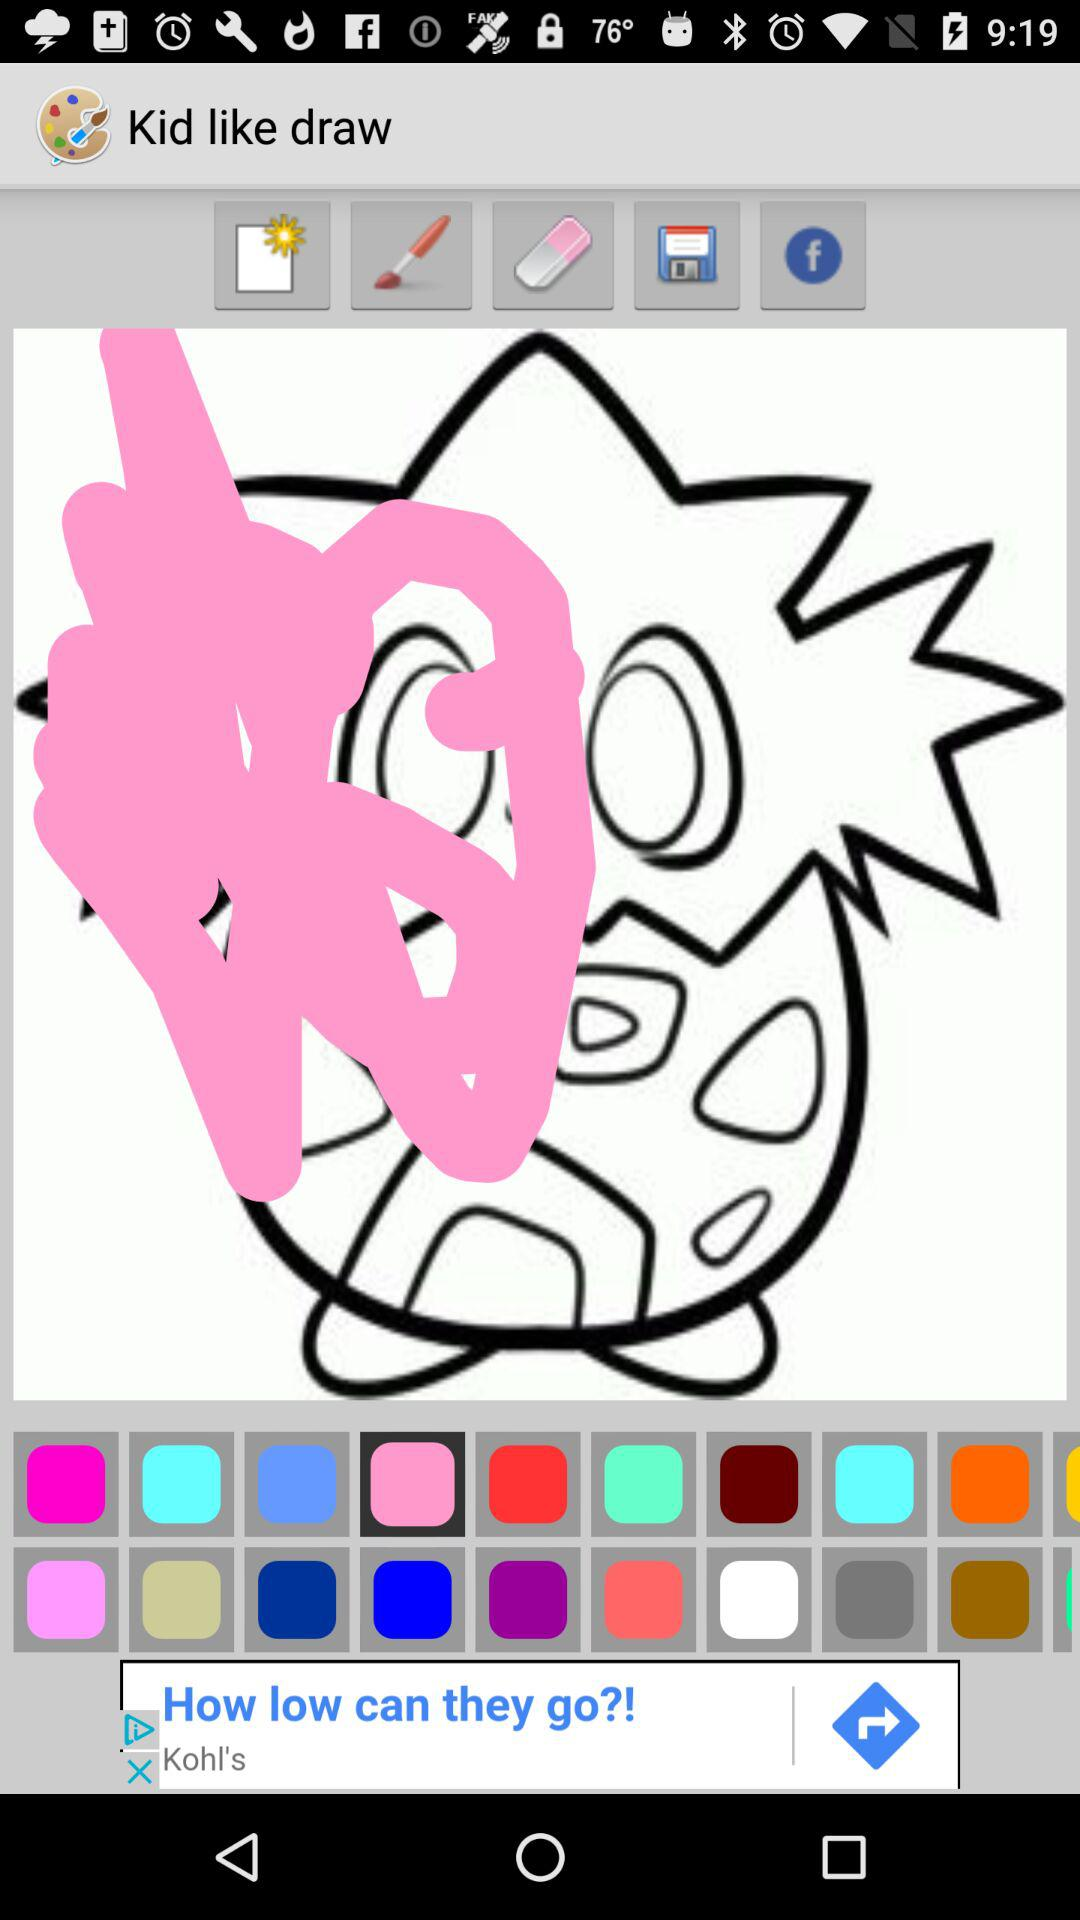What is the application name? The application name is "Paint for Whatsapp". 